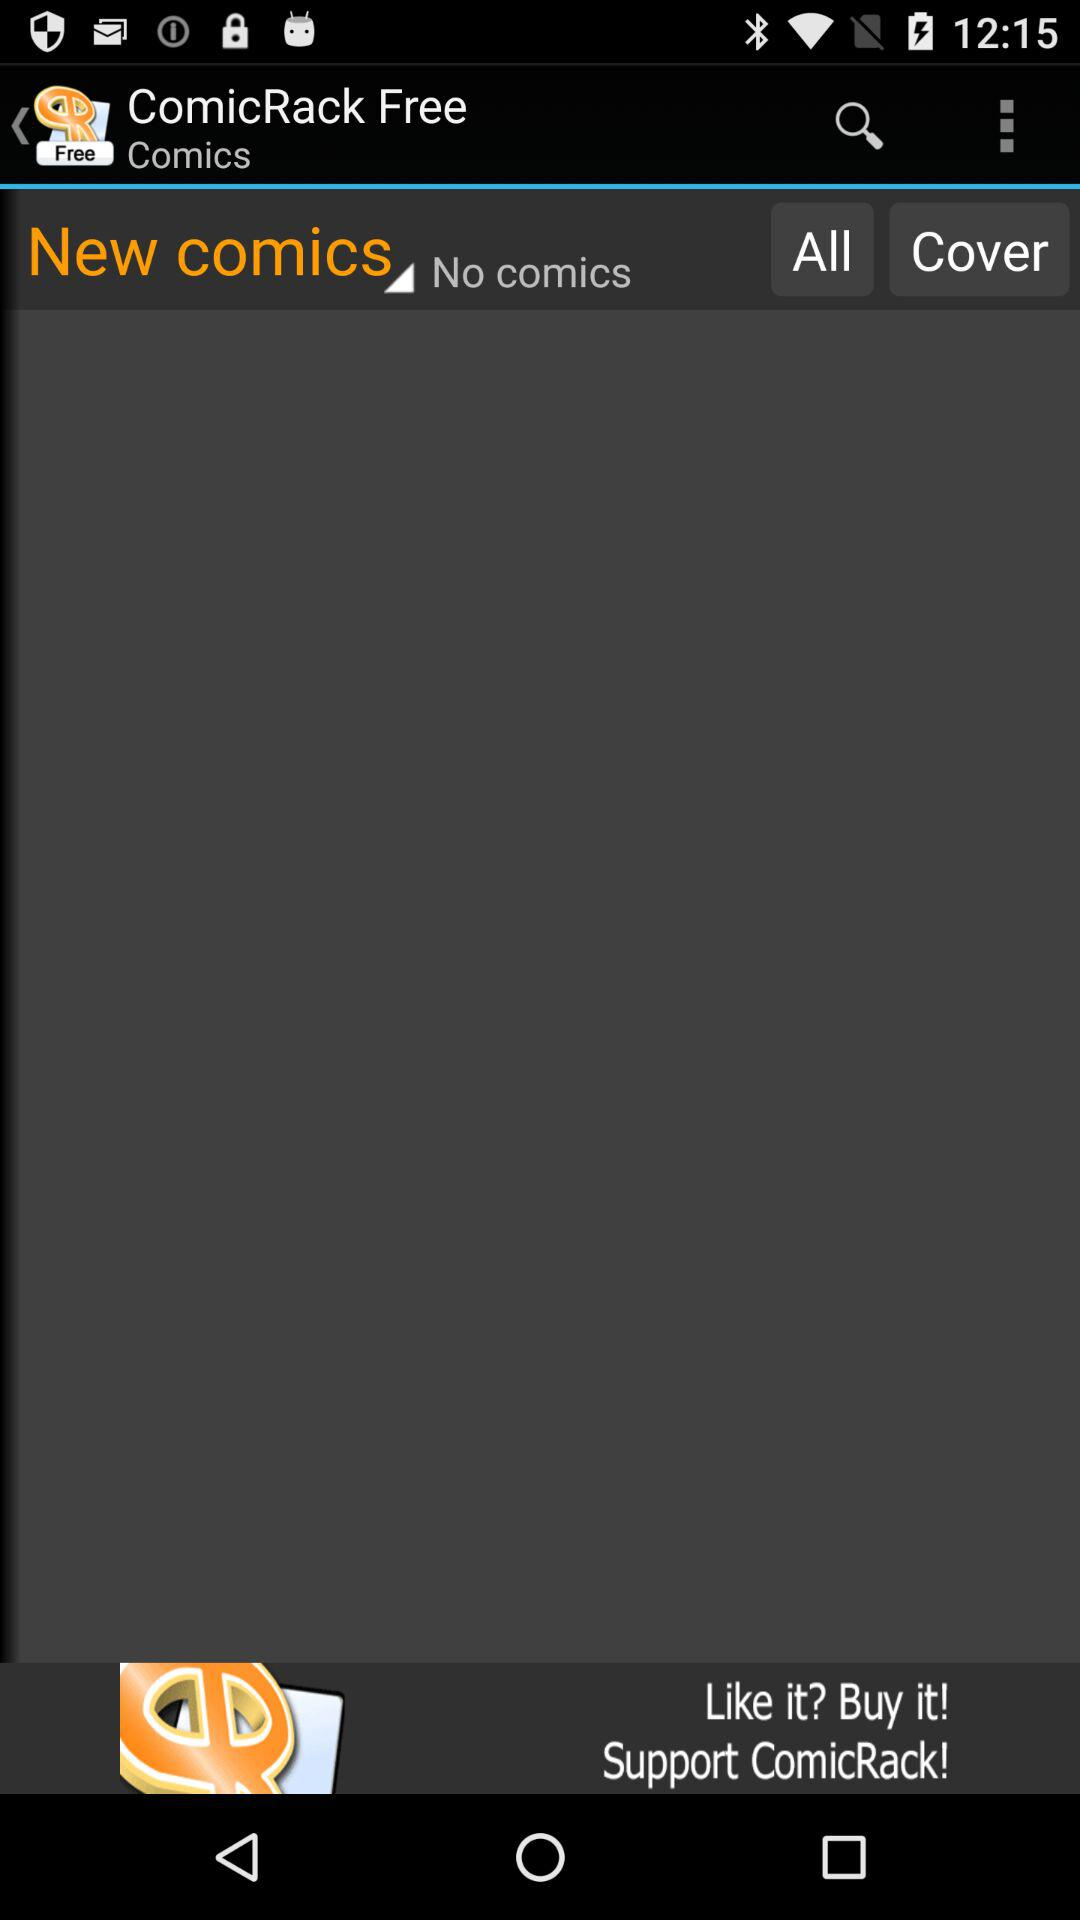What is the name of the application? The name of the application is "ComicRack Free". 